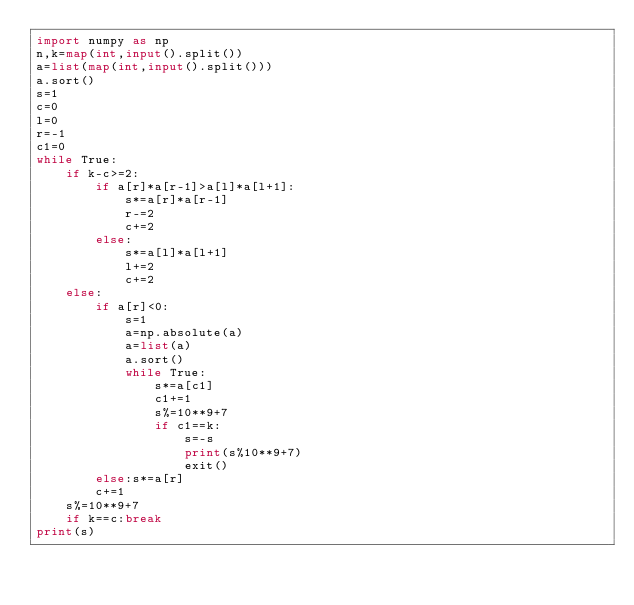Convert code to text. <code><loc_0><loc_0><loc_500><loc_500><_Python_>import numpy as np
n,k=map(int,input().split())
a=list(map(int,input().split()))
a.sort()
s=1
c=0
l=0
r=-1
c1=0
while True:
    if k-c>=2:
        if a[r]*a[r-1]>a[l]*a[l+1]:
            s*=a[r]*a[r-1]
            r-=2
            c+=2
        else:
            s*=a[l]*a[l+1]
            l+=2
            c+=2
    else:
        if a[r]<0:
            s=1
            a=np.absolute(a)
            a=list(a)
            a.sort()
            while True:
                s*=a[c1]
                c1+=1
                s%=10**9+7
                if c1==k:
                    s=-s
                    print(s%10**9+7)
                    exit()
        else:s*=a[r]
        c+=1
    s%=10**9+7
    if k==c:break
print(s)</code> 